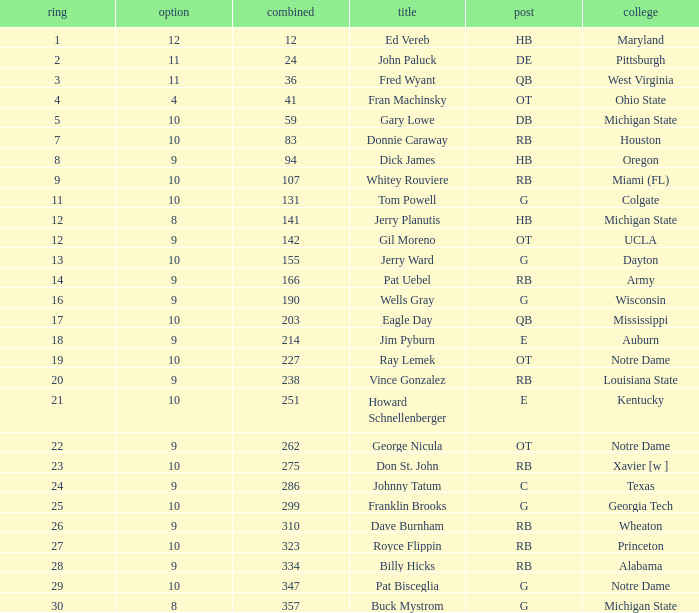What is the total number of overall picks that were after pick 9 and went to Auburn College? 0.0. 